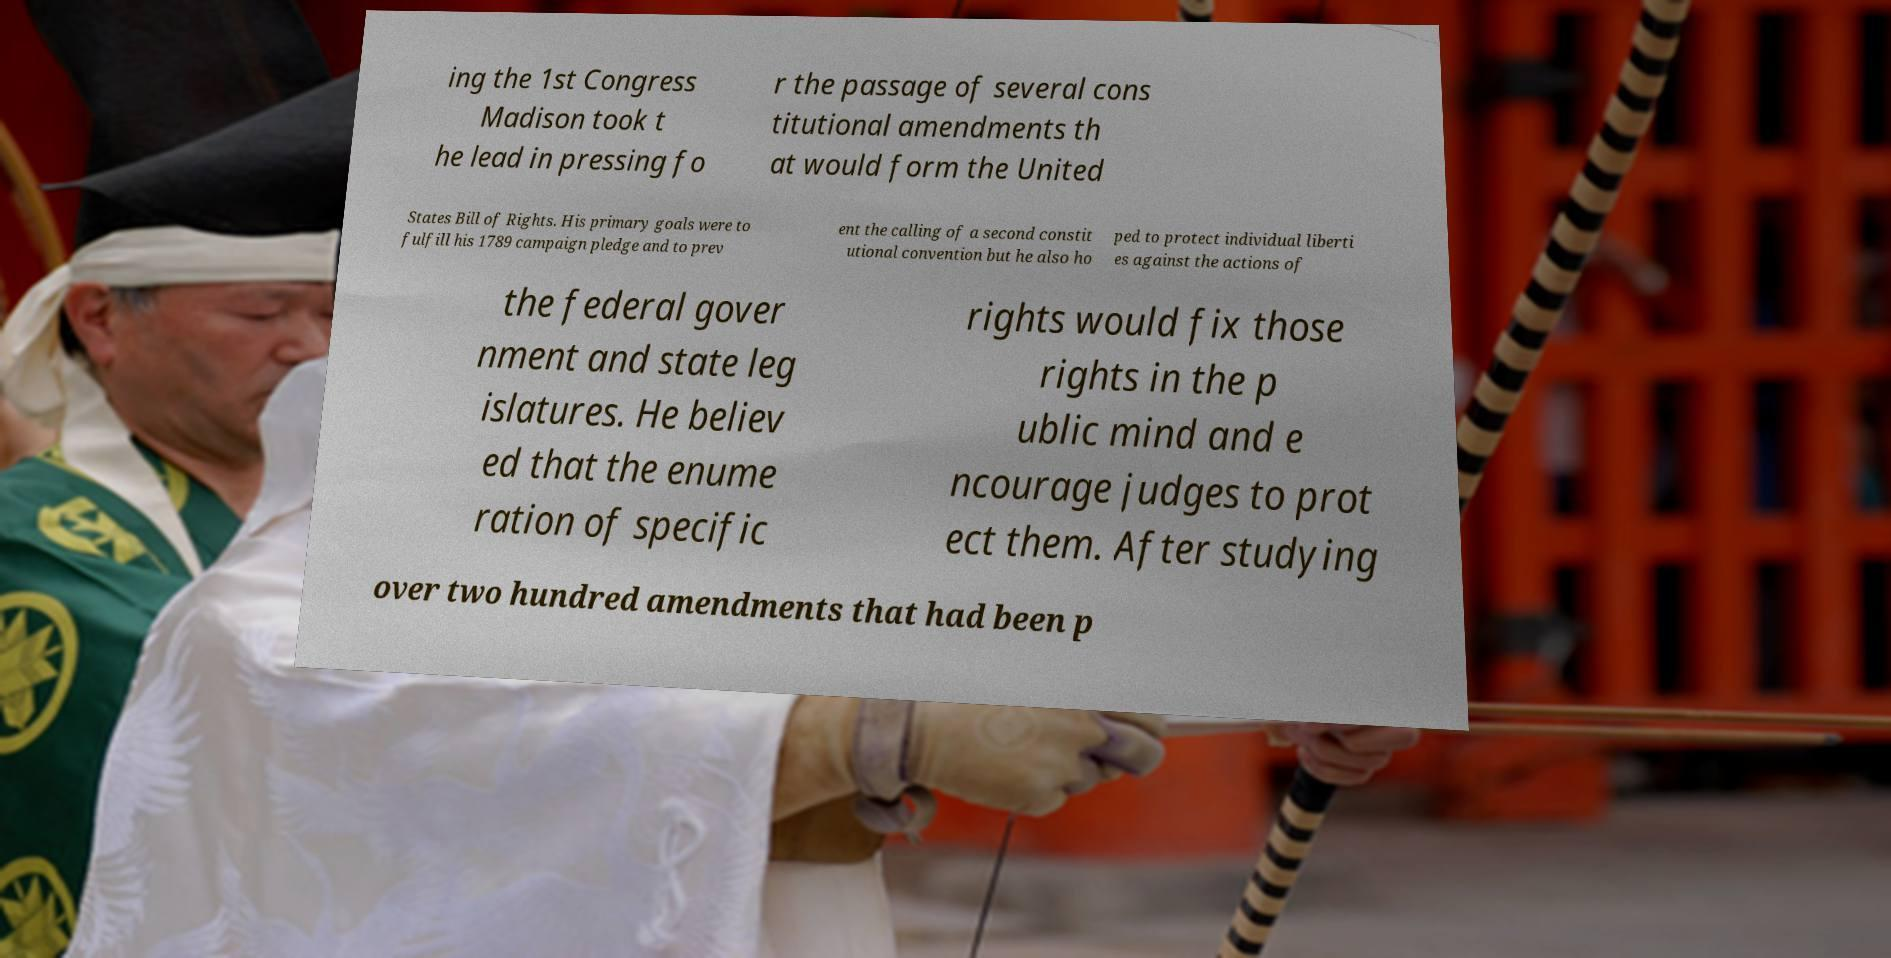What messages or text are displayed in this image? I need them in a readable, typed format. ing the 1st Congress Madison took t he lead in pressing fo r the passage of several cons titutional amendments th at would form the United States Bill of Rights. His primary goals were to fulfill his 1789 campaign pledge and to prev ent the calling of a second constit utional convention but he also ho ped to protect individual liberti es against the actions of the federal gover nment and state leg islatures. He believ ed that the enume ration of specific rights would fix those rights in the p ublic mind and e ncourage judges to prot ect them. After studying over two hundred amendments that had been p 